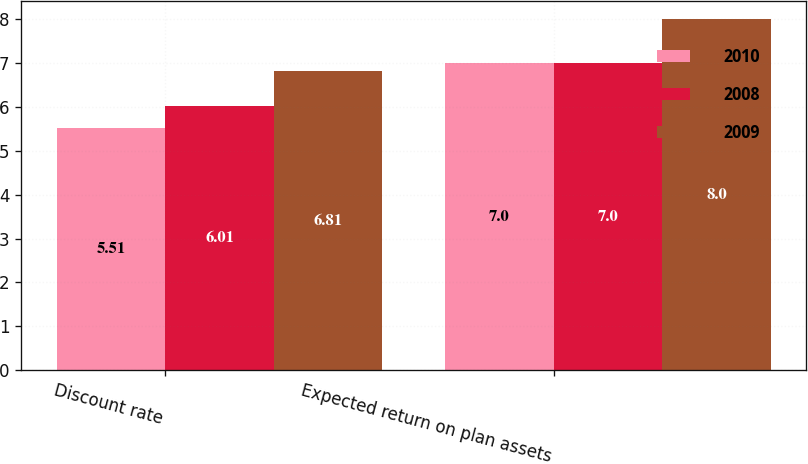<chart> <loc_0><loc_0><loc_500><loc_500><stacked_bar_chart><ecel><fcel>Discount rate<fcel>Expected return on plan assets<nl><fcel>2010<fcel>5.51<fcel>7<nl><fcel>2008<fcel>6.01<fcel>7<nl><fcel>2009<fcel>6.81<fcel>8<nl></chart> 